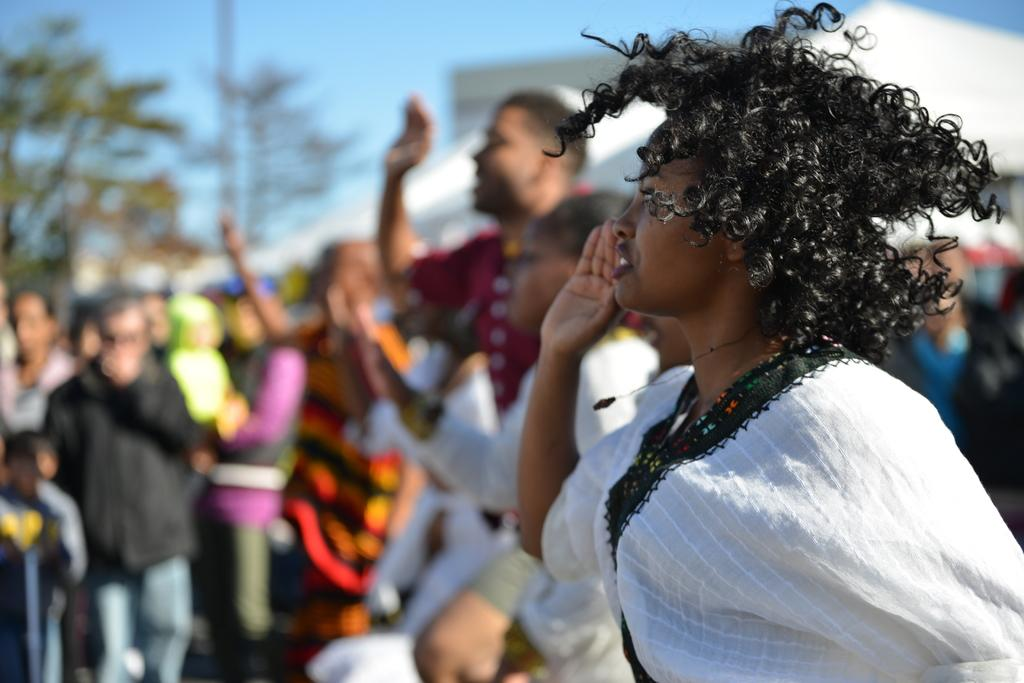How many people are in the image? There is a group of people in the image, but the exact number cannot be determined from the provided facts. What can be seen in the background of the image? There are tents and trees in the background of the image, and the sky is also visible. What type of statement can be seen on the sign near the ocean in the image? There is no sign or ocean present in the image, so it is not possible to answer that question. 